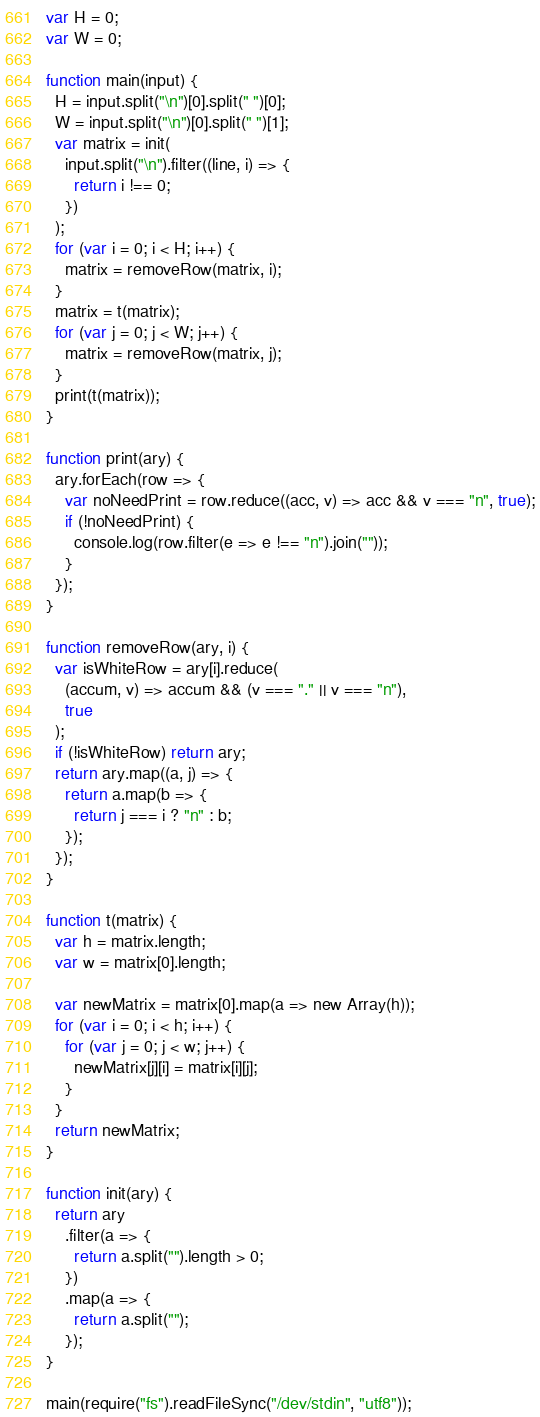Convert code to text. <code><loc_0><loc_0><loc_500><loc_500><_JavaScript_>var H = 0;
var W = 0;

function main(input) {
  H = input.split("\n")[0].split(" ")[0];
  W = input.split("\n")[0].split(" ")[1];
  var matrix = init(
    input.split("\n").filter((line, i) => {
      return i !== 0;
    })
  );
  for (var i = 0; i < H; i++) {
    matrix = removeRow(matrix, i);
  }
  matrix = t(matrix);
  for (var j = 0; j < W; j++) {
    matrix = removeRow(matrix, j);
  }
  print(t(matrix));
}

function print(ary) {
  ary.forEach(row => {
    var noNeedPrint = row.reduce((acc, v) => acc && v === "n", true);
    if (!noNeedPrint) {
      console.log(row.filter(e => e !== "n").join(""));
    }
  });
}

function removeRow(ary, i) {
  var isWhiteRow = ary[i].reduce(
    (accum, v) => accum && (v === "." || v === "n"),
    true
  );
  if (!isWhiteRow) return ary;
  return ary.map((a, j) => {
    return a.map(b => {
      return j === i ? "n" : b;
    });
  });
}

function t(matrix) {
  var h = matrix.length;
  var w = matrix[0].length;

  var newMatrix = matrix[0].map(a => new Array(h));
  for (var i = 0; i < h; i++) {
    for (var j = 0; j < w; j++) {
      newMatrix[j][i] = matrix[i][j];
    }
  }
  return newMatrix;
}

function init(ary) {
  return ary
    .filter(a => {
      return a.split("").length > 0;
    })
    .map(a => {
      return a.split("");
    });
}

main(require("fs").readFileSync("/dev/stdin", "utf8"));
</code> 